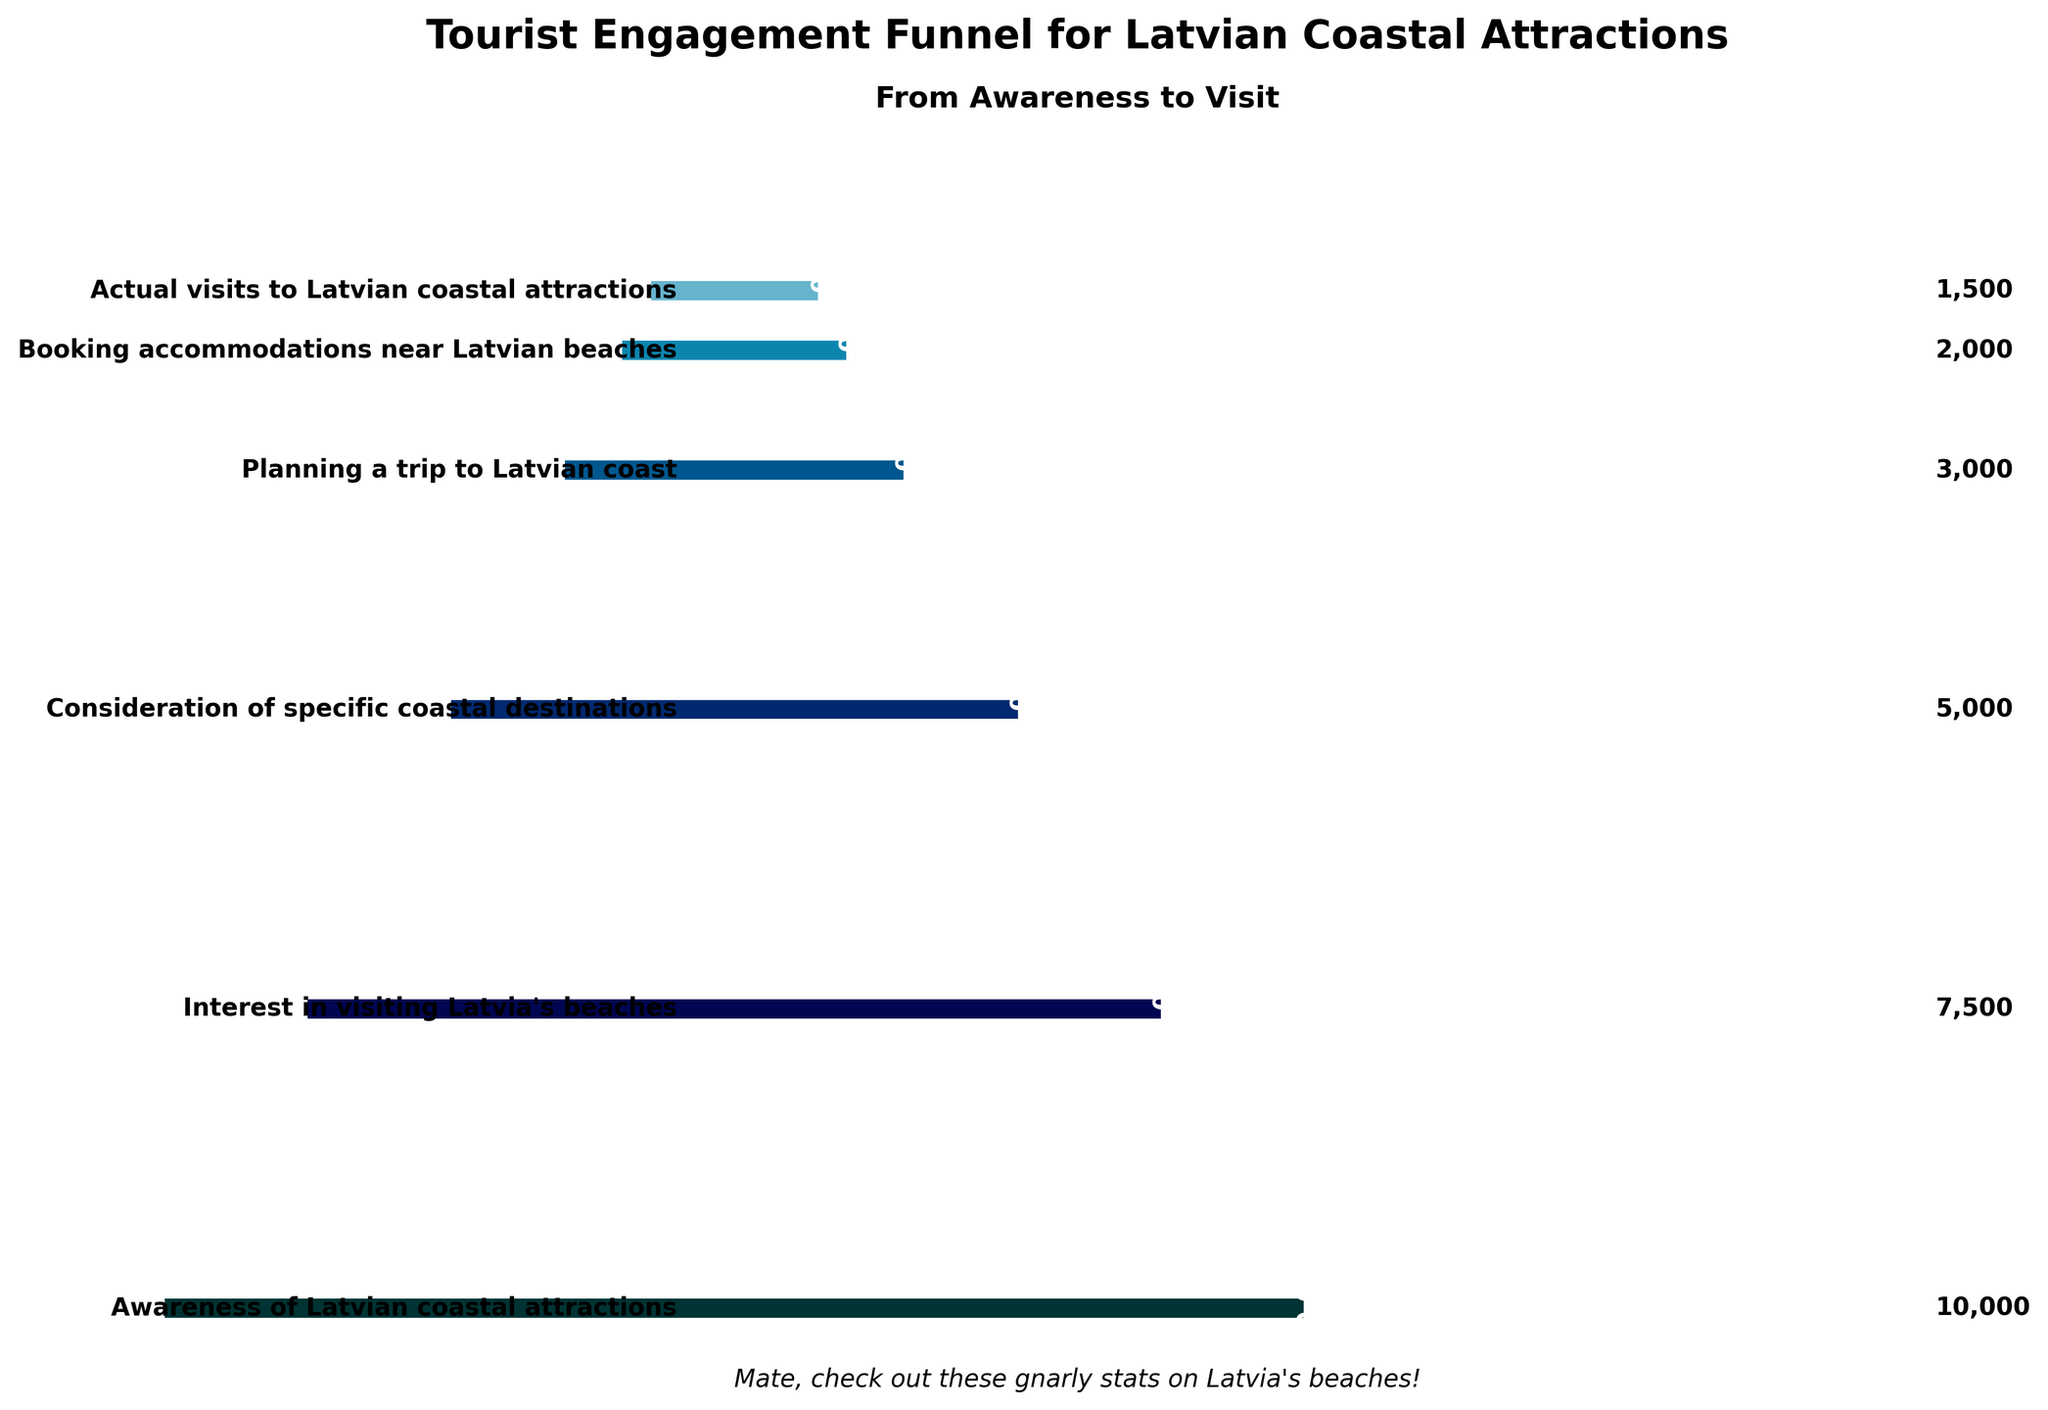what's the title of the figure? The title is prominently displayed at the top of the figure in bold and large font. It states "Tourist Engagement Funnel for Latvian Coastal Attractions" followed by a subtitle "From Awareness to Visit".
Answer: Tourist Engagement Funnel for Latvian Coastal Attractions What is the percentage decrease from the stage 'Awareness of Latvian coastal attractions' to 'Interest in visiting Latvia's beaches'? The Awareness stage has 10000 people, representing 100%. The Interest stage has 7500 people, which is 75% of the Awareness stage. The percentage decrease is 100% - 75%.
Answer: 25% Which transition stage has the largest drop in the number of people? By comparing the drop between each stage, the transition from 'Consideration of specific coastal destinations' (5000 people) to 'Planning a trip to Latvian coast' (3000 people) has the largest drop, which is 2000 people.
Answer: Consideration to Planning How many more people planned a trip compared to those who booked accommodations? The number of people who planned a trip is 3000, and those who booked accommodations are 2000. The difference is calculated by subtracting the latter from the former: 3000 - 2000.
Answer: 1000 What stage has the smallest number of people? The final stage 'Actual visits to Latvian coastal attractions' has the smallest number of people, which is 1500.
Answer: Actual visits to Latvian coastal attractions What is the overall conversion rate from 'Awareness of Latvian coastal attractions' to 'Actual visits to Latvian coastal attractions'? The conversion rate is calculated by dividing the number of people who actually visited (1500) by the number of people initially aware (10000) and multiplying by 100 to get a percentage. (1500 / 10000) * 100 = 15%.
Answer: 15% If you combine the number of people in the 'Consideration of specific coastal destinations' and 'Planning a trip to Latvian coast' stages, what is the total? Sum of the two stages: 5000 (Consideration) + 3000 (Planning) = 8000 people.
Answer: 8000 What is the ratio of people interested in visiting Latvia's beaches to those who actually visit? The ratio is calculated by dividing the number of people interested (7500) by the number of people who actually visit (1500): 7500 / 1500 = 5.
Answer: 5:1 